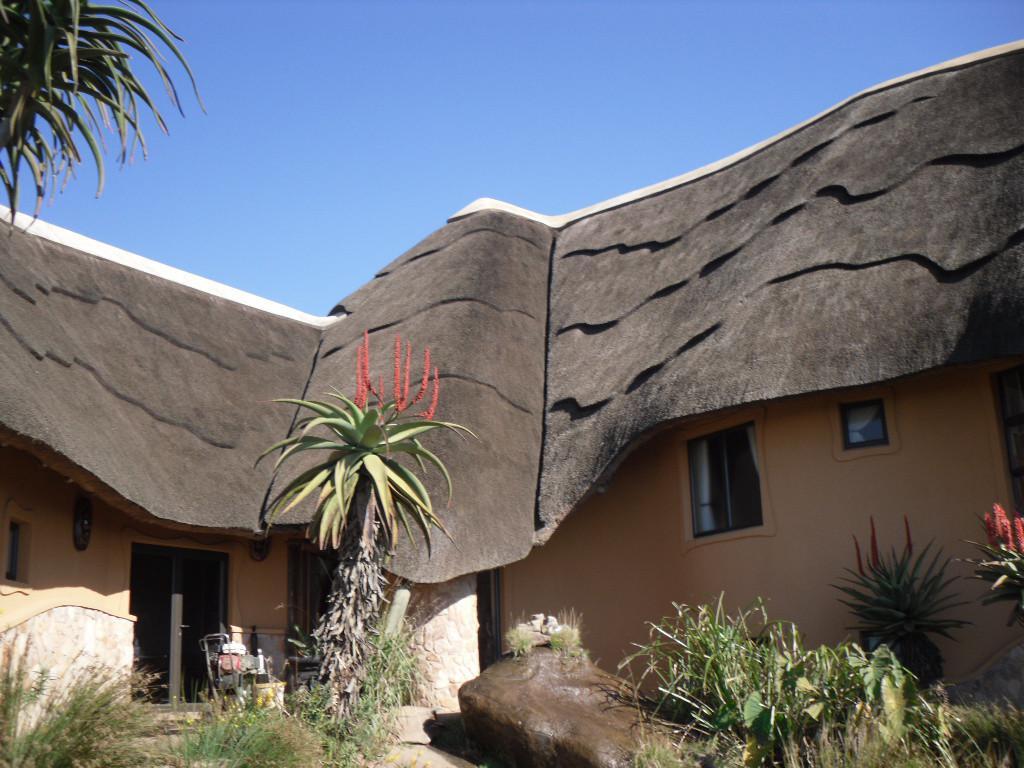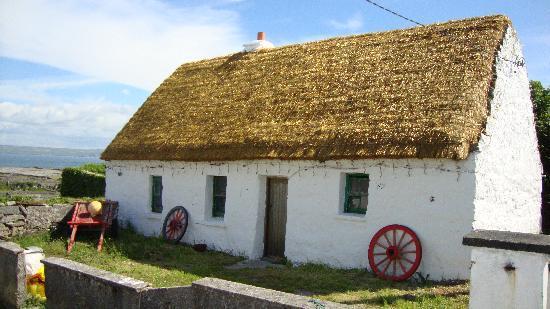The first image is the image on the left, the second image is the image on the right. Assess this claim about the two images: "In at least one image there is a white house with two windows, a straw roof and two chimneys.". Correct or not? Answer yes or no. No. The first image is the image on the left, the second image is the image on the right. Given the left and right images, does the statement "One image shows a rectangular white building with a single window flanking each side of the door, a chimney on each end, and a roof with a straight bottom edge bordered with a dotted line of stones." hold true? Answer yes or no. No. 